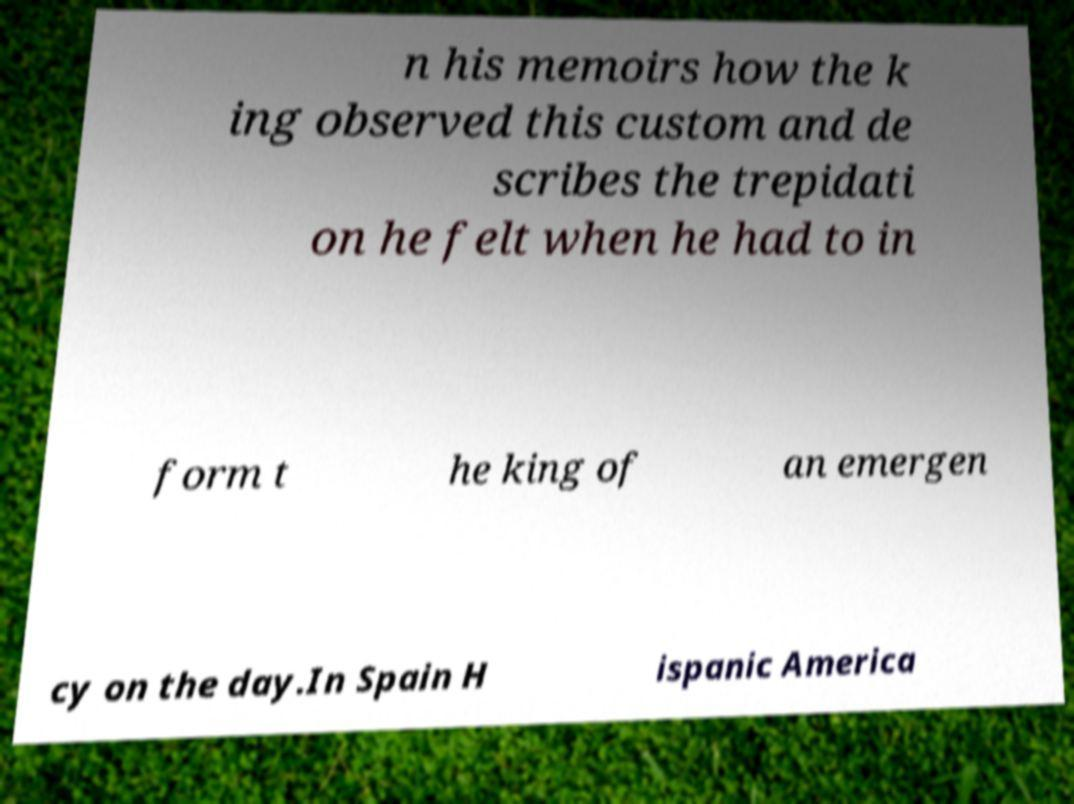Could you extract and type out the text from this image? n his memoirs how the k ing observed this custom and de scribes the trepidati on he felt when he had to in form t he king of an emergen cy on the day.In Spain H ispanic America 